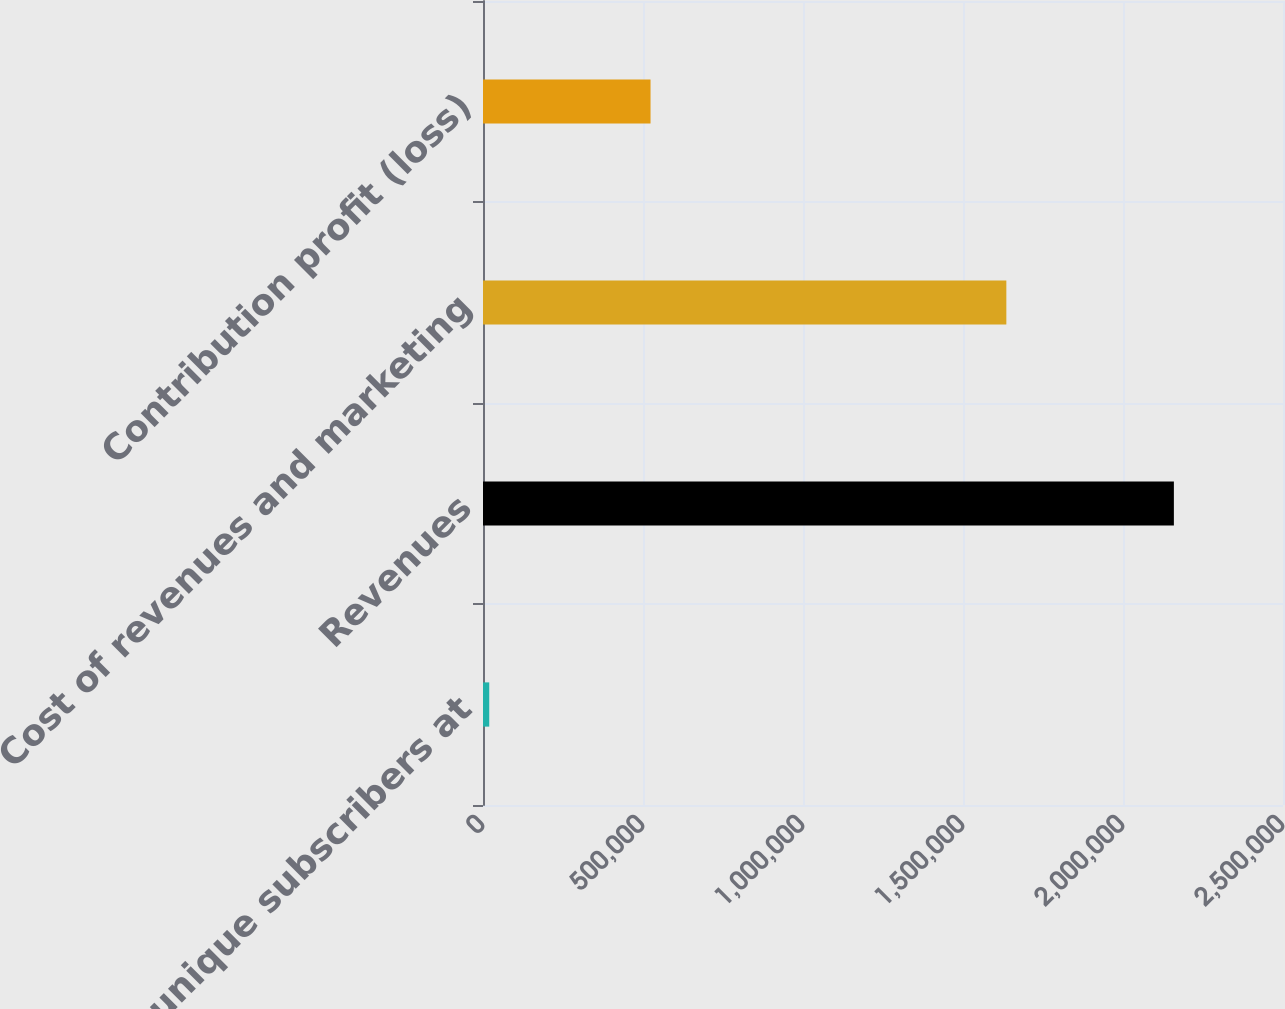<chart> <loc_0><loc_0><loc_500><loc_500><bar_chart><fcel>Total unique subscribers at<fcel>Revenues<fcel>Cost of revenues and marketing<fcel>Contribution profit (loss)<nl><fcel>19501<fcel>2.15901e+06<fcel>1.63546e+06<fcel>523549<nl></chart> 